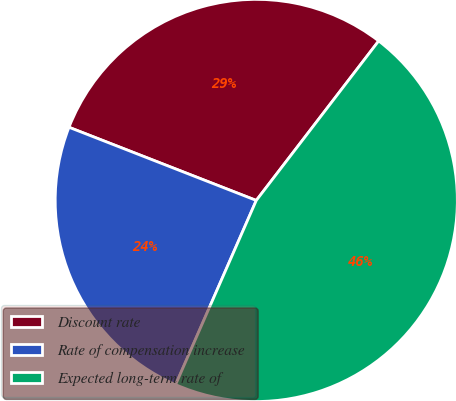Convert chart to OTSL. <chart><loc_0><loc_0><loc_500><loc_500><pie_chart><fcel>Discount rate<fcel>Rate of compensation increase<fcel>Expected long-term rate of<nl><fcel>29.49%<fcel>24.36%<fcel>46.15%<nl></chart> 